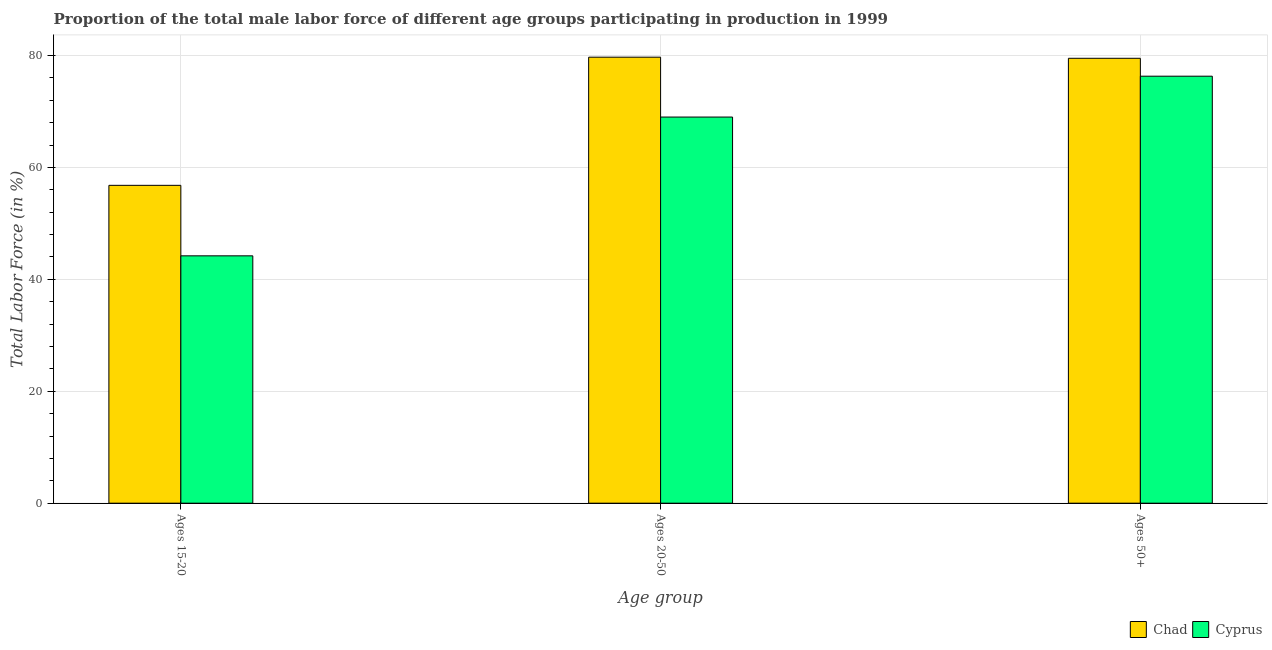How many bars are there on the 3rd tick from the left?
Provide a short and direct response. 2. How many bars are there on the 3rd tick from the right?
Ensure brevity in your answer.  2. What is the label of the 3rd group of bars from the left?
Make the answer very short. Ages 50+. What is the percentage of male labor force above age 50 in Chad?
Ensure brevity in your answer.  79.5. Across all countries, what is the maximum percentage of male labor force within the age group 15-20?
Make the answer very short. 56.8. Across all countries, what is the minimum percentage of male labor force within the age group 15-20?
Your answer should be compact. 44.2. In which country was the percentage of male labor force within the age group 15-20 maximum?
Offer a terse response. Chad. In which country was the percentage of male labor force within the age group 15-20 minimum?
Provide a succinct answer. Cyprus. What is the total percentage of male labor force within the age group 15-20 in the graph?
Your answer should be very brief. 101. What is the difference between the percentage of male labor force within the age group 20-50 in Chad and that in Cyprus?
Make the answer very short. 10.7. What is the difference between the percentage of male labor force within the age group 20-50 in Chad and the percentage of male labor force within the age group 15-20 in Cyprus?
Keep it short and to the point. 35.5. What is the average percentage of male labor force above age 50 per country?
Ensure brevity in your answer.  77.9. What is the difference between the percentage of male labor force within the age group 20-50 and percentage of male labor force above age 50 in Chad?
Your answer should be very brief. 0.2. In how many countries, is the percentage of male labor force within the age group 20-50 greater than 12 %?
Keep it short and to the point. 2. What is the ratio of the percentage of male labor force above age 50 in Cyprus to that in Chad?
Provide a short and direct response. 0.96. What is the difference between the highest and the second highest percentage of male labor force within the age group 15-20?
Offer a very short reply. 12.6. What is the difference between the highest and the lowest percentage of male labor force above age 50?
Offer a very short reply. 3.2. Is the sum of the percentage of male labor force within the age group 15-20 in Cyprus and Chad greater than the maximum percentage of male labor force above age 50 across all countries?
Your answer should be very brief. Yes. What does the 1st bar from the left in Ages 15-20 represents?
Make the answer very short. Chad. What does the 2nd bar from the right in Ages 15-20 represents?
Offer a very short reply. Chad. How many bars are there?
Offer a very short reply. 6. Are all the bars in the graph horizontal?
Offer a terse response. No. Does the graph contain any zero values?
Ensure brevity in your answer.  No. Where does the legend appear in the graph?
Make the answer very short. Bottom right. How many legend labels are there?
Give a very brief answer. 2. What is the title of the graph?
Ensure brevity in your answer.  Proportion of the total male labor force of different age groups participating in production in 1999. Does "Indonesia" appear as one of the legend labels in the graph?
Ensure brevity in your answer.  No. What is the label or title of the X-axis?
Offer a terse response. Age group. What is the label or title of the Y-axis?
Your response must be concise. Total Labor Force (in %). What is the Total Labor Force (in %) in Chad in Ages 15-20?
Make the answer very short. 56.8. What is the Total Labor Force (in %) of Cyprus in Ages 15-20?
Give a very brief answer. 44.2. What is the Total Labor Force (in %) in Chad in Ages 20-50?
Your answer should be compact. 79.7. What is the Total Labor Force (in %) in Chad in Ages 50+?
Offer a very short reply. 79.5. What is the Total Labor Force (in %) of Cyprus in Ages 50+?
Your answer should be very brief. 76.3. Across all Age group, what is the maximum Total Labor Force (in %) of Chad?
Ensure brevity in your answer.  79.7. Across all Age group, what is the maximum Total Labor Force (in %) in Cyprus?
Provide a short and direct response. 76.3. Across all Age group, what is the minimum Total Labor Force (in %) of Chad?
Your answer should be very brief. 56.8. Across all Age group, what is the minimum Total Labor Force (in %) of Cyprus?
Your answer should be very brief. 44.2. What is the total Total Labor Force (in %) of Chad in the graph?
Provide a succinct answer. 216. What is the total Total Labor Force (in %) of Cyprus in the graph?
Ensure brevity in your answer.  189.5. What is the difference between the Total Labor Force (in %) in Chad in Ages 15-20 and that in Ages 20-50?
Your answer should be very brief. -22.9. What is the difference between the Total Labor Force (in %) in Cyprus in Ages 15-20 and that in Ages 20-50?
Your response must be concise. -24.8. What is the difference between the Total Labor Force (in %) in Chad in Ages 15-20 and that in Ages 50+?
Make the answer very short. -22.7. What is the difference between the Total Labor Force (in %) in Cyprus in Ages 15-20 and that in Ages 50+?
Keep it short and to the point. -32.1. What is the difference between the Total Labor Force (in %) in Chad in Ages 20-50 and that in Ages 50+?
Provide a short and direct response. 0.2. What is the difference between the Total Labor Force (in %) of Cyprus in Ages 20-50 and that in Ages 50+?
Your answer should be compact. -7.3. What is the difference between the Total Labor Force (in %) in Chad in Ages 15-20 and the Total Labor Force (in %) in Cyprus in Ages 50+?
Provide a short and direct response. -19.5. What is the difference between the Total Labor Force (in %) of Chad in Ages 20-50 and the Total Labor Force (in %) of Cyprus in Ages 50+?
Keep it short and to the point. 3.4. What is the average Total Labor Force (in %) of Cyprus per Age group?
Provide a succinct answer. 63.17. What is the difference between the Total Labor Force (in %) of Chad and Total Labor Force (in %) of Cyprus in Ages 20-50?
Ensure brevity in your answer.  10.7. What is the difference between the Total Labor Force (in %) in Chad and Total Labor Force (in %) in Cyprus in Ages 50+?
Keep it short and to the point. 3.2. What is the ratio of the Total Labor Force (in %) in Chad in Ages 15-20 to that in Ages 20-50?
Keep it short and to the point. 0.71. What is the ratio of the Total Labor Force (in %) in Cyprus in Ages 15-20 to that in Ages 20-50?
Make the answer very short. 0.64. What is the ratio of the Total Labor Force (in %) of Chad in Ages 15-20 to that in Ages 50+?
Provide a short and direct response. 0.71. What is the ratio of the Total Labor Force (in %) of Cyprus in Ages 15-20 to that in Ages 50+?
Your response must be concise. 0.58. What is the ratio of the Total Labor Force (in %) of Chad in Ages 20-50 to that in Ages 50+?
Provide a short and direct response. 1. What is the ratio of the Total Labor Force (in %) in Cyprus in Ages 20-50 to that in Ages 50+?
Your response must be concise. 0.9. What is the difference between the highest and the second highest Total Labor Force (in %) of Cyprus?
Give a very brief answer. 7.3. What is the difference between the highest and the lowest Total Labor Force (in %) in Chad?
Ensure brevity in your answer.  22.9. What is the difference between the highest and the lowest Total Labor Force (in %) in Cyprus?
Your answer should be compact. 32.1. 